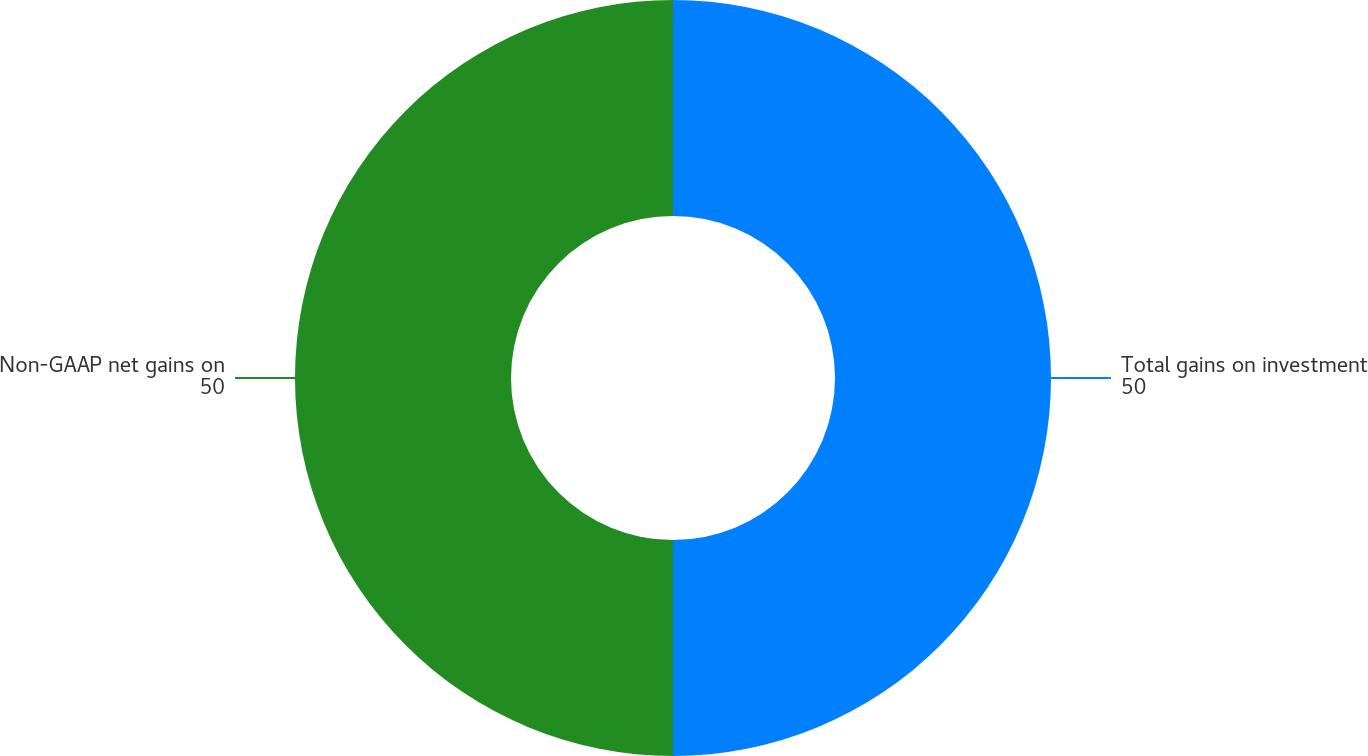Convert chart. <chart><loc_0><loc_0><loc_500><loc_500><pie_chart><fcel>Total gains on investment<fcel>Non-GAAP net gains on<nl><fcel>50.0%<fcel>50.0%<nl></chart> 